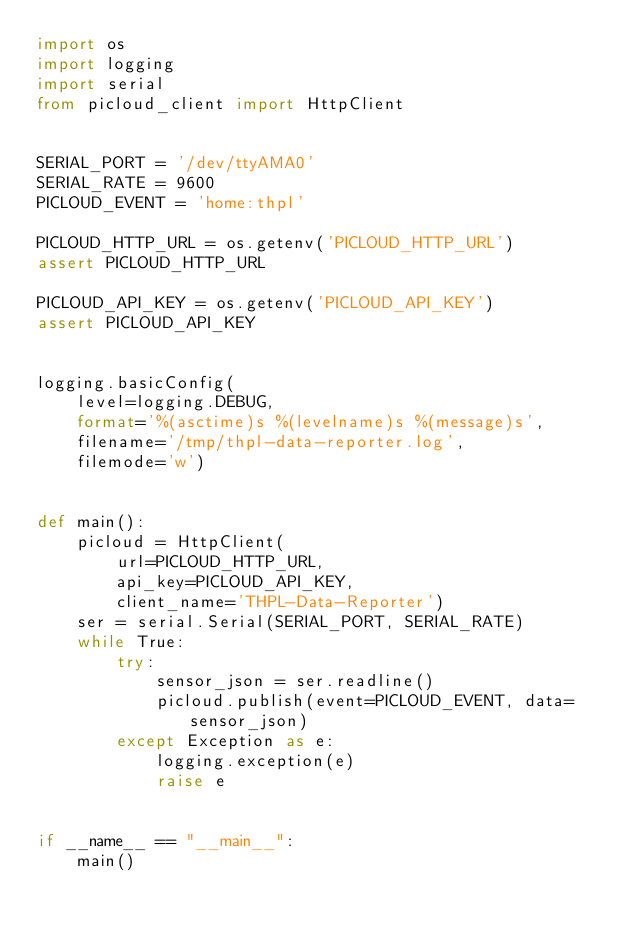<code> <loc_0><loc_0><loc_500><loc_500><_Python_>import os
import logging
import serial
from picloud_client import HttpClient


SERIAL_PORT = '/dev/ttyAMA0'
SERIAL_RATE = 9600
PICLOUD_EVENT = 'home:thpl'

PICLOUD_HTTP_URL = os.getenv('PICLOUD_HTTP_URL')
assert PICLOUD_HTTP_URL

PICLOUD_API_KEY = os.getenv('PICLOUD_API_KEY')
assert PICLOUD_API_KEY


logging.basicConfig(
    level=logging.DEBUG,
    format='%(asctime)s %(levelname)s %(message)s',
    filename='/tmp/thpl-data-reporter.log',
    filemode='w')


def main():
    picloud = HttpClient(
        url=PICLOUD_HTTP_URL,
        api_key=PICLOUD_API_KEY,
        client_name='THPL-Data-Reporter')
    ser = serial.Serial(SERIAL_PORT, SERIAL_RATE)
    while True:
        try:
            sensor_json = ser.readline()
            picloud.publish(event=PICLOUD_EVENT, data=sensor_json)
        except Exception as e:
            logging.exception(e)
            raise e


if __name__ == "__main__":
    main()
</code> 